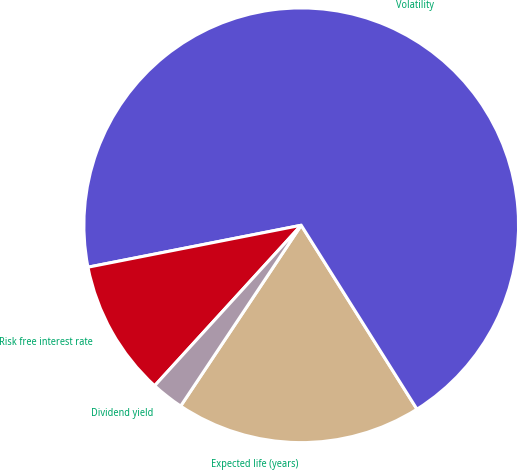Convert chart to OTSL. <chart><loc_0><loc_0><loc_500><loc_500><pie_chart><fcel>Expected life (years)<fcel>Volatility<fcel>Risk free interest rate<fcel>Dividend yield<nl><fcel>18.3%<fcel>69.15%<fcel>10.13%<fcel>2.42%<nl></chart> 